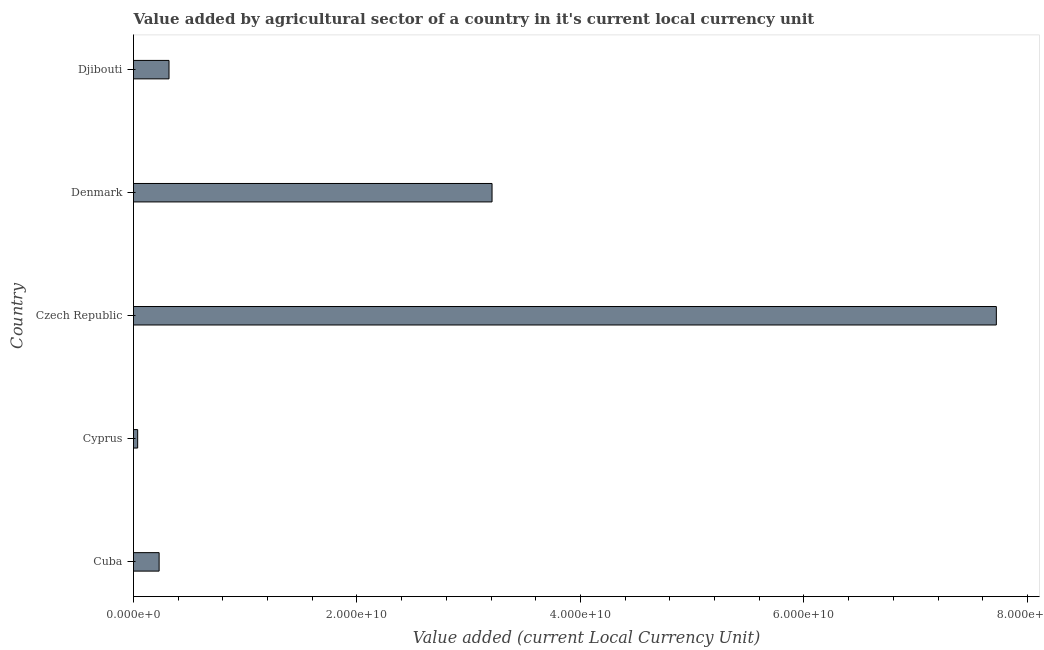Does the graph contain any zero values?
Your answer should be very brief. No. What is the title of the graph?
Your answer should be very brief. Value added by agricultural sector of a country in it's current local currency unit. What is the label or title of the X-axis?
Offer a terse response. Value added (current Local Currency Unit). What is the label or title of the Y-axis?
Keep it short and to the point. Country. What is the value added by agriculture sector in Denmark?
Your response must be concise. 3.21e+1. Across all countries, what is the maximum value added by agriculture sector?
Offer a terse response. 7.72e+1. Across all countries, what is the minimum value added by agriculture sector?
Your answer should be compact. 3.72e+08. In which country was the value added by agriculture sector maximum?
Provide a short and direct response. Czech Republic. In which country was the value added by agriculture sector minimum?
Keep it short and to the point. Cyprus. What is the sum of the value added by agriculture sector?
Your answer should be compact. 1.15e+11. What is the difference between the value added by agriculture sector in Cyprus and Djibouti?
Offer a terse response. -2.81e+09. What is the average value added by agriculture sector per country?
Your response must be concise. 2.30e+1. What is the median value added by agriculture sector?
Ensure brevity in your answer.  3.18e+09. What is the ratio of the value added by agriculture sector in Cyprus to that in Denmark?
Offer a terse response. 0.01. Is the value added by agriculture sector in Denmark less than that in Djibouti?
Make the answer very short. No. Is the difference between the value added by agriculture sector in Cyprus and Djibouti greater than the difference between any two countries?
Provide a succinct answer. No. What is the difference between the highest and the second highest value added by agriculture sector?
Give a very brief answer. 4.51e+1. What is the difference between the highest and the lowest value added by agriculture sector?
Ensure brevity in your answer.  7.68e+1. In how many countries, is the value added by agriculture sector greater than the average value added by agriculture sector taken over all countries?
Provide a short and direct response. 2. Are all the bars in the graph horizontal?
Offer a terse response. Yes. How many countries are there in the graph?
Offer a terse response. 5. Are the values on the major ticks of X-axis written in scientific E-notation?
Provide a short and direct response. Yes. What is the Value added (current Local Currency Unit) of Cuba?
Your answer should be compact. 2.29e+09. What is the Value added (current Local Currency Unit) in Cyprus?
Ensure brevity in your answer.  3.72e+08. What is the Value added (current Local Currency Unit) in Czech Republic?
Offer a very short reply. 7.72e+1. What is the Value added (current Local Currency Unit) of Denmark?
Provide a short and direct response. 3.21e+1. What is the Value added (current Local Currency Unit) of Djibouti?
Provide a short and direct response. 3.18e+09. What is the difference between the Value added (current Local Currency Unit) in Cuba and Cyprus?
Your response must be concise. 1.92e+09. What is the difference between the Value added (current Local Currency Unit) in Cuba and Czech Republic?
Provide a short and direct response. -7.49e+1. What is the difference between the Value added (current Local Currency Unit) in Cuba and Denmark?
Offer a very short reply. -2.98e+1. What is the difference between the Value added (current Local Currency Unit) in Cuba and Djibouti?
Keep it short and to the point. -8.86e+08. What is the difference between the Value added (current Local Currency Unit) in Cyprus and Czech Republic?
Provide a succinct answer. -7.68e+1. What is the difference between the Value added (current Local Currency Unit) in Cyprus and Denmark?
Give a very brief answer. -3.17e+1. What is the difference between the Value added (current Local Currency Unit) in Cyprus and Djibouti?
Make the answer very short. -2.81e+09. What is the difference between the Value added (current Local Currency Unit) in Czech Republic and Denmark?
Offer a terse response. 4.51e+1. What is the difference between the Value added (current Local Currency Unit) in Czech Republic and Djibouti?
Make the answer very short. 7.40e+1. What is the difference between the Value added (current Local Currency Unit) in Denmark and Djibouti?
Your answer should be very brief. 2.89e+1. What is the ratio of the Value added (current Local Currency Unit) in Cuba to that in Cyprus?
Offer a very short reply. 6.16. What is the ratio of the Value added (current Local Currency Unit) in Cuba to that in Denmark?
Make the answer very short. 0.07. What is the ratio of the Value added (current Local Currency Unit) in Cuba to that in Djibouti?
Offer a very short reply. 0.72. What is the ratio of the Value added (current Local Currency Unit) in Cyprus to that in Czech Republic?
Your response must be concise. 0.01. What is the ratio of the Value added (current Local Currency Unit) in Cyprus to that in Denmark?
Keep it short and to the point. 0.01. What is the ratio of the Value added (current Local Currency Unit) in Cyprus to that in Djibouti?
Provide a succinct answer. 0.12. What is the ratio of the Value added (current Local Currency Unit) in Czech Republic to that in Denmark?
Give a very brief answer. 2.41. What is the ratio of the Value added (current Local Currency Unit) in Czech Republic to that in Djibouti?
Your response must be concise. 24.3. What is the ratio of the Value added (current Local Currency Unit) in Denmark to that in Djibouti?
Give a very brief answer. 10.1. 